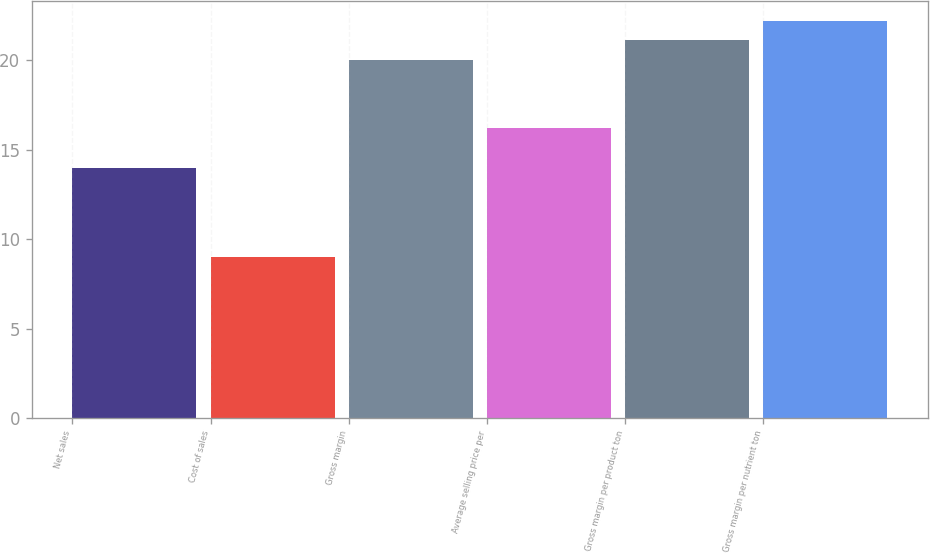Convert chart. <chart><loc_0><loc_0><loc_500><loc_500><bar_chart><fcel>Net sales<fcel>Cost of sales<fcel>Gross margin<fcel>Average selling price per<fcel>Gross margin per product ton<fcel>Gross margin per nutrient ton<nl><fcel>14<fcel>9<fcel>20<fcel>16.2<fcel>21.1<fcel>22.2<nl></chart> 